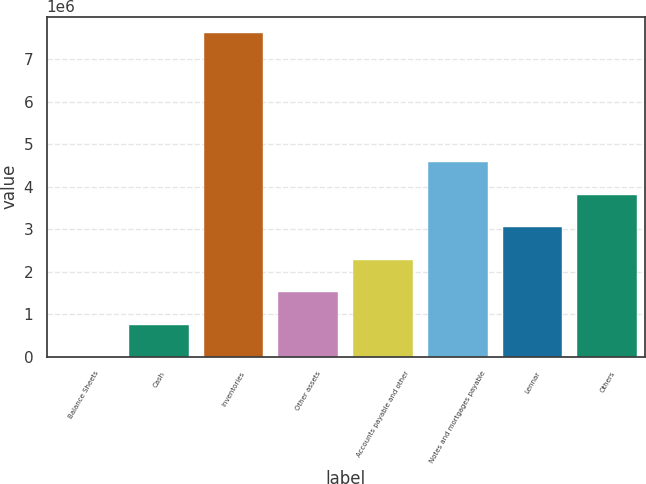Convert chart. <chart><loc_0><loc_0><loc_500><loc_500><bar_chart><fcel>Balance Sheets<fcel>Cash<fcel>Inventories<fcel>Other assets<fcel>Accounts payable and other<fcel>Notes and mortgages payable<fcel>Lennar<fcel>Others<nl><fcel>2005<fcel>763353<fcel>7.61549e+06<fcel>1.5247e+06<fcel>2.28605e+06<fcel>4.5701e+06<fcel>3.0474e+06<fcel>3.80875e+06<nl></chart> 